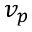Convert formula to latex. <formula><loc_0><loc_0><loc_500><loc_500>v _ { p }</formula> 